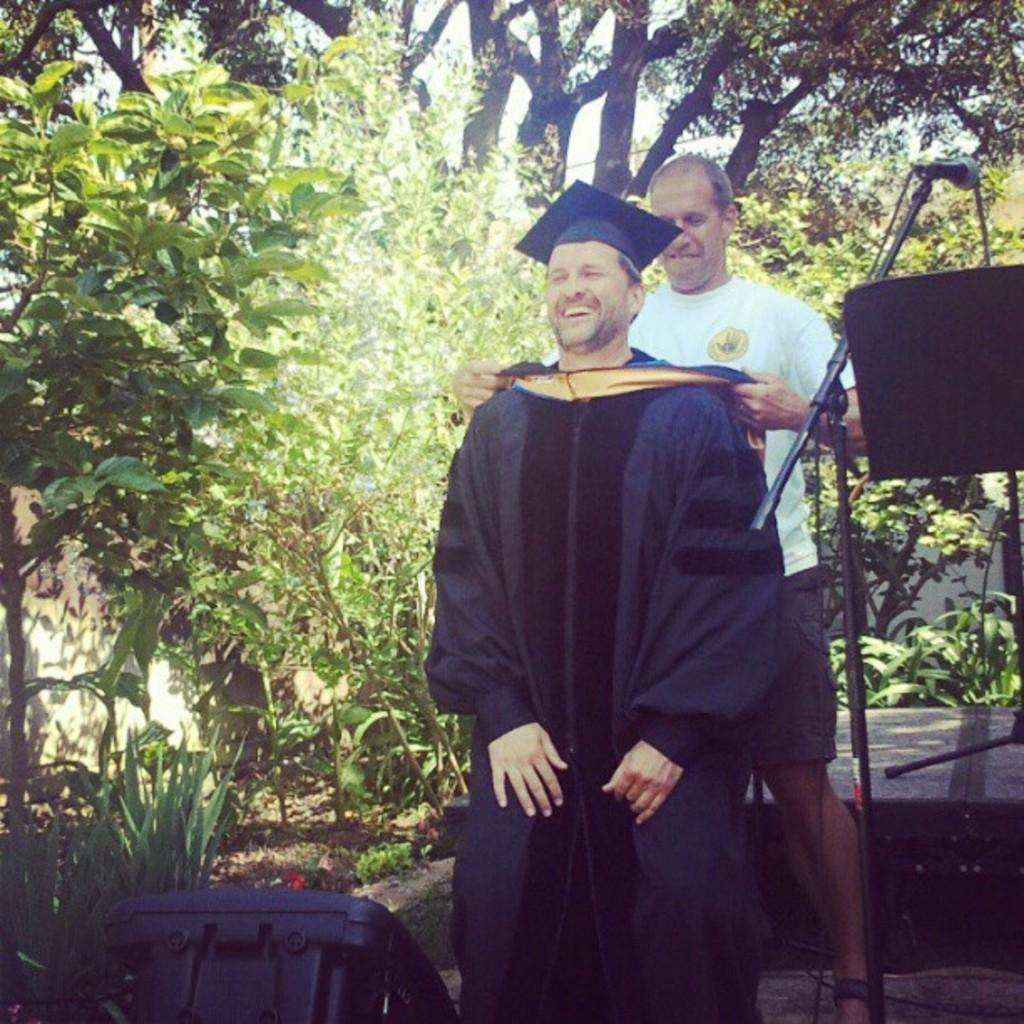How many people are in the image? There are two persons standing in the image. What are the expressions on their faces? The persons are smiling. What type of natural elements can be seen in the image? There are trees and plants in the image. What object is used for amplifying sound? A microphone (mic) is present in the image. What other unspecified objects are in the image? There are other unspecified objects in the image, but we cannot identify them without more information. What is visible in the background of the image? There is a wall and the sky visible in the image. What type of cap is the wish wearing in the image? There is no cap or wish present in the image. How many cables are connected to the microphone in the image? There is no cable connected to the microphone in the image. 